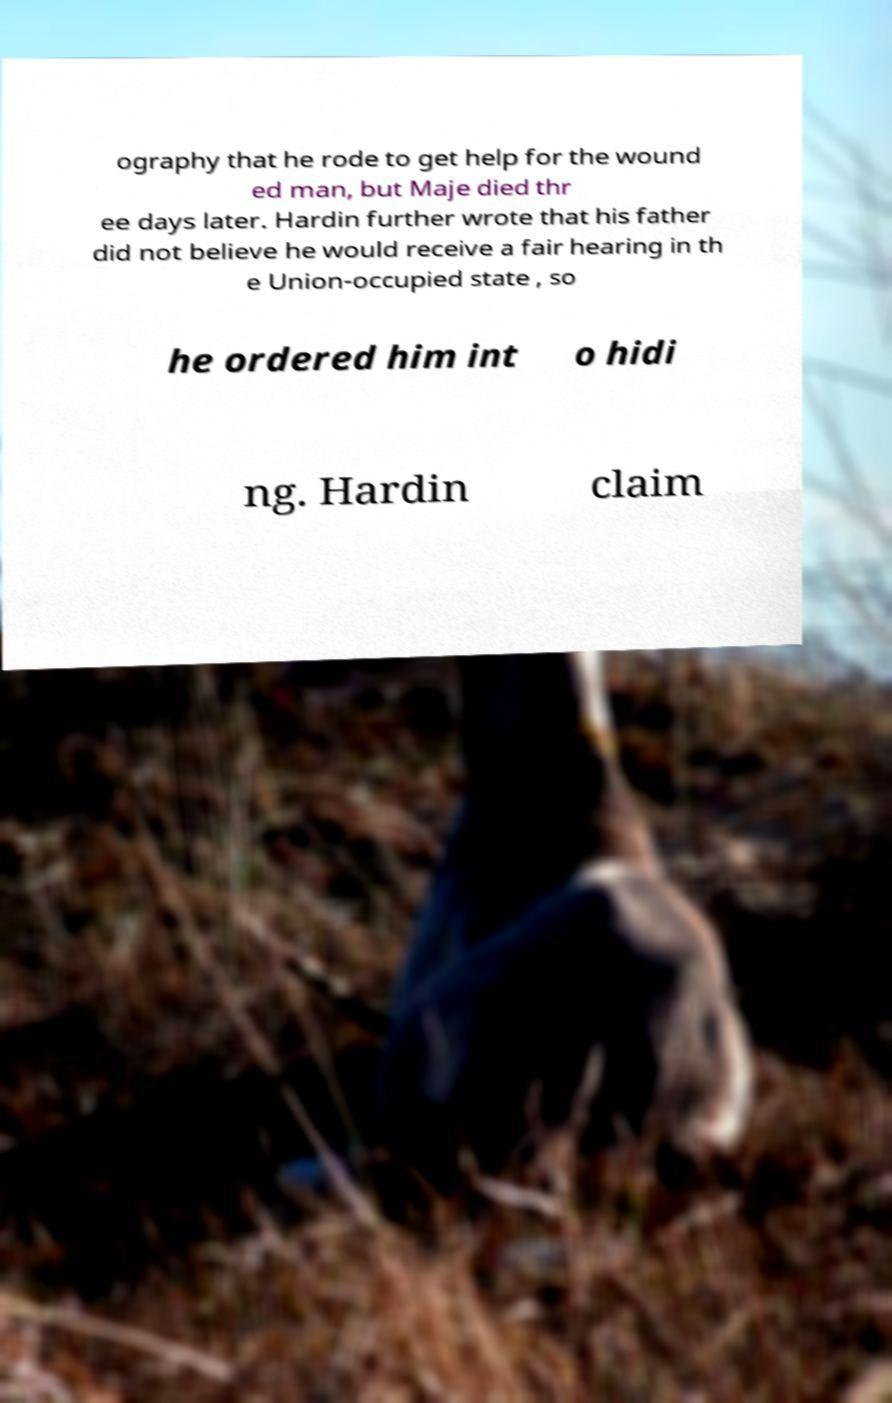For documentation purposes, I need the text within this image transcribed. Could you provide that? ography that he rode to get help for the wound ed man, but Maje died thr ee days later. Hardin further wrote that his father did not believe he would receive a fair hearing in th e Union-occupied state , so he ordered him int o hidi ng. Hardin claim 